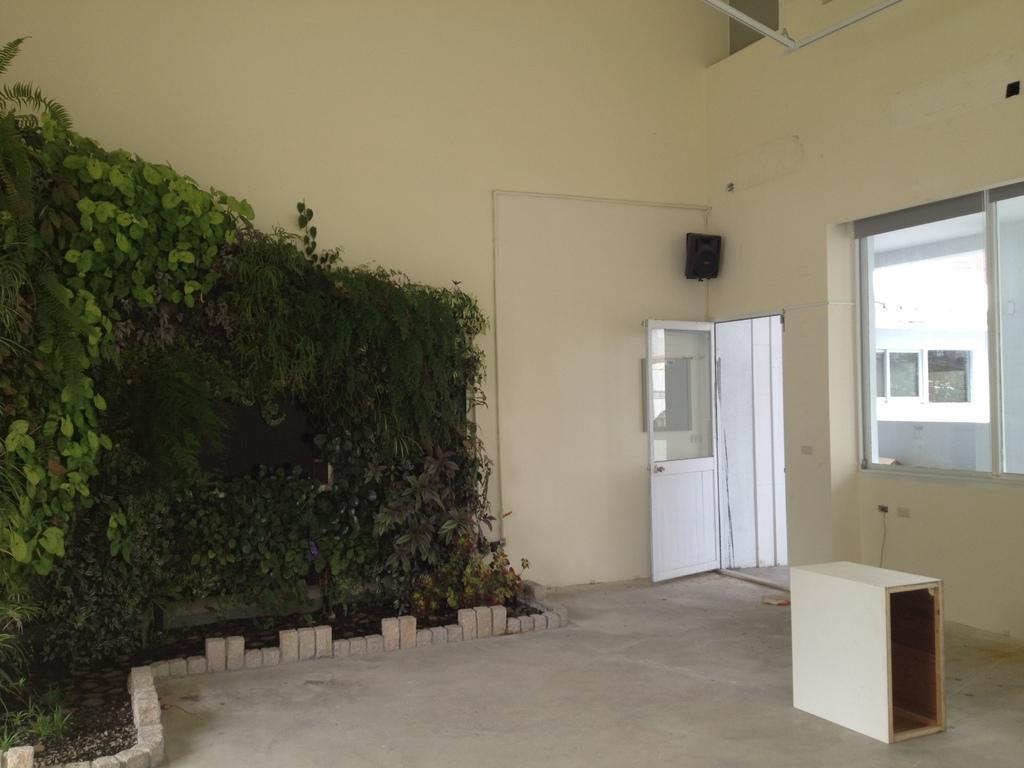Please provide a concise description of this image. In this image I can see the inner part of the room and I can see plants in green color. Background I can see few windows, a door in white color and the wall is in cream color. 